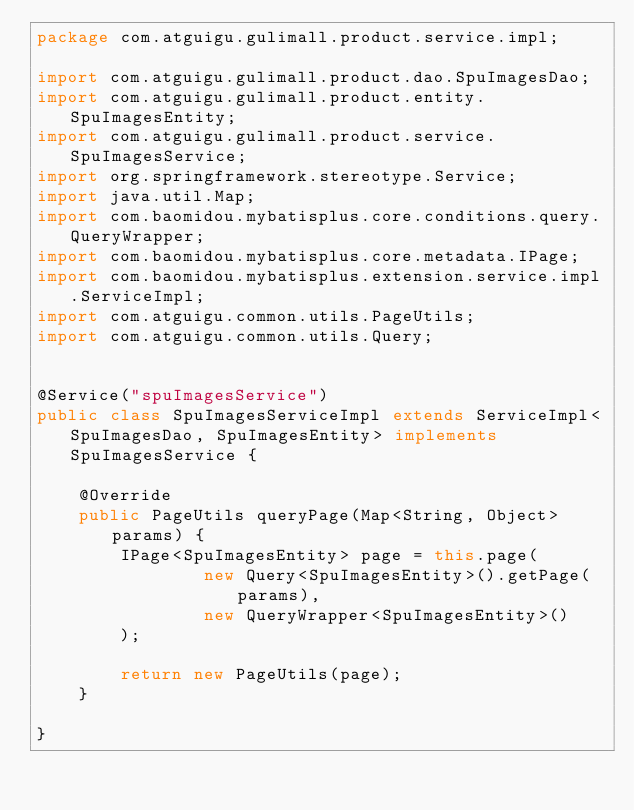Convert code to text. <code><loc_0><loc_0><loc_500><loc_500><_Java_>package com.atguigu.gulimall.product.service.impl;

import com.atguigu.gulimall.product.dao.SpuImagesDao;
import com.atguigu.gulimall.product.entity.SpuImagesEntity;
import com.atguigu.gulimall.product.service.SpuImagesService;
import org.springframework.stereotype.Service;
import java.util.Map;
import com.baomidou.mybatisplus.core.conditions.query.QueryWrapper;
import com.baomidou.mybatisplus.core.metadata.IPage;
import com.baomidou.mybatisplus.extension.service.impl.ServiceImpl;
import com.atguigu.common.utils.PageUtils;
import com.atguigu.common.utils.Query;


@Service("spuImagesService")
public class SpuImagesServiceImpl extends ServiceImpl<SpuImagesDao, SpuImagesEntity> implements SpuImagesService {

    @Override
    public PageUtils queryPage(Map<String, Object> params) {
        IPage<SpuImagesEntity> page = this.page(
                new Query<SpuImagesEntity>().getPage(params),
                new QueryWrapper<SpuImagesEntity>()
        );

        return new PageUtils(page);
    }

}</code> 